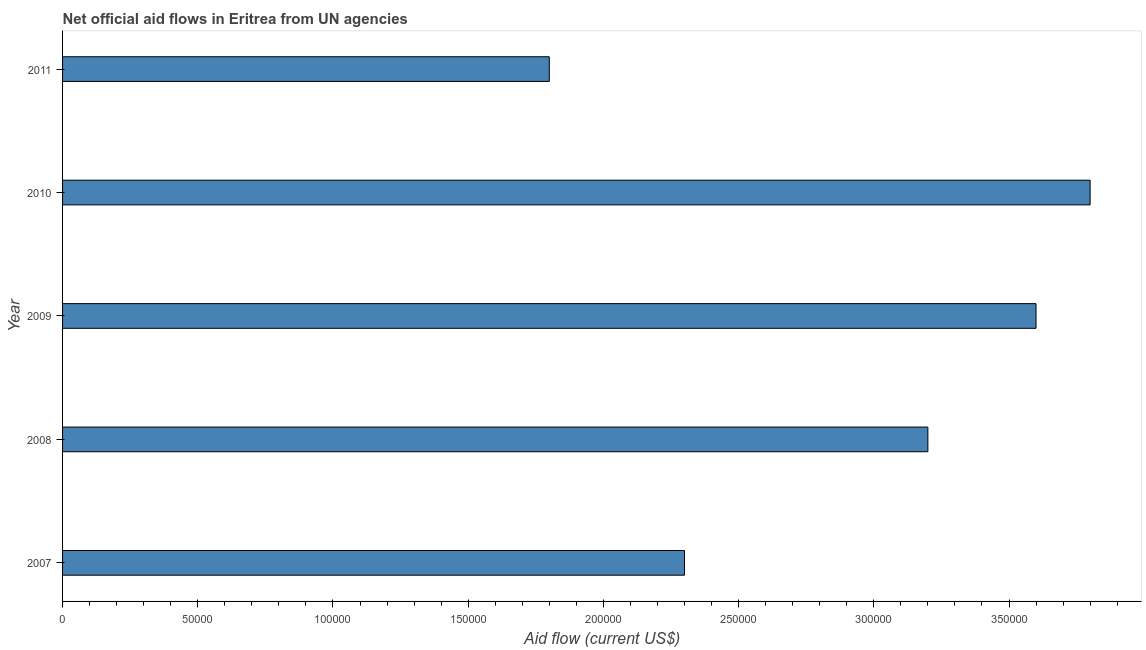Does the graph contain any zero values?
Provide a succinct answer. No. What is the title of the graph?
Offer a terse response. Net official aid flows in Eritrea from UN agencies. What is the sum of the net official flows from un agencies?
Provide a succinct answer. 1.47e+06. What is the difference between the net official flows from un agencies in 2008 and 2009?
Ensure brevity in your answer.  -4.00e+04. What is the average net official flows from un agencies per year?
Ensure brevity in your answer.  2.94e+05. In how many years, is the net official flows from un agencies greater than 150000 US$?
Your answer should be very brief. 5. What is the ratio of the net official flows from un agencies in 2010 to that in 2011?
Give a very brief answer. 2.11. Is the difference between the net official flows from un agencies in 2009 and 2010 greater than the difference between any two years?
Provide a succinct answer. No. What is the difference between the highest and the second highest net official flows from un agencies?
Offer a very short reply. 2.00e+04. Is the sum of the net official flows from un agencies in 2009 and 2011 greater than the maximum net official flows from un agencies across all years?
Your answer should be very brief. Yes. Are all the bars in the graph horizontal?
Offer a terse response. Yes. What is the difference between two consecutive major ticks on the X-axis?
Provide a short and direct response. 5.00e+04. Are the values on the major ticks of X-axis written in scientific E-notation?
Ensure brevity in your answer.  No. What is the Aid flow (current US$) in 2007?
Provide a short and direct response. 2.30e+05. What is the Aid flow (current US$) of 2008?
Provide a succinct answer. 3.20e+05. What is the Aid flow (current US$) of 2009?
Offer a very short reply. 3.60e+05. What is the Aid flow (current US$) in 2010?
Your answer should be very brief. 3.80e+05. What is the Aid flow (current US$) of 2011?
Your answer should be compact. 1.80e+05. What is the difference between the Aid flow (current US$) in 2007 and 2008?
Your answer should be very brief. -9.00e+04. What is the difference between the Aid flow (current US$) in 2007 and 2011?
Offer a very short reply. 5.00e+04. What is the difference between the Aid flow (current US$) in 2008 and 2010?
Offer a terse response. -6.00e+04. What is the difference between the Aid flow (current US$) in 2009 and 2011?
Give a very brief answer. 1.80e+05. What is the difference between the Aid flow (current US$) in 2010 and 2011?
Offer a terse response. 2.00e+05. What is the ratio of the Aid flow (current US$) in 2007 to that in 2008?
Offer a very short reply. 0.72. What is the ratio of the Aid flow (current US$) in 2007 to that in 2009?
Provide a short and direct response. 0.64. What is the ratio of the Aid flow (current US$) in 2007 to that in 2010?
Offer a very short reply. 0.6. What is the ratio of the Aid flow (current US$) in 2007 to that in 2011?
Give a very brief answer. 1.28. What is the ratio of the Aid flow (current US$) in 2008 to that in 2009?
Provide a succinct answer. 0.89. What is the ratio of the Aid flow (current US$) in 2008 to that in 2010?
Offer a very short reply. 0.84. What is the ratio of the Aid flow (current US$) in 2008 to that in 2011?
Give a very brief answer. 1.78. What is the ratio of the Aid flow (current US$) in 2009 to that in 2010?
Make the answer very short. 0.95. What is the ratio of the Aid flow (current US$) in 2010 to that in 2011?
Your response must be concise. 2.11. 